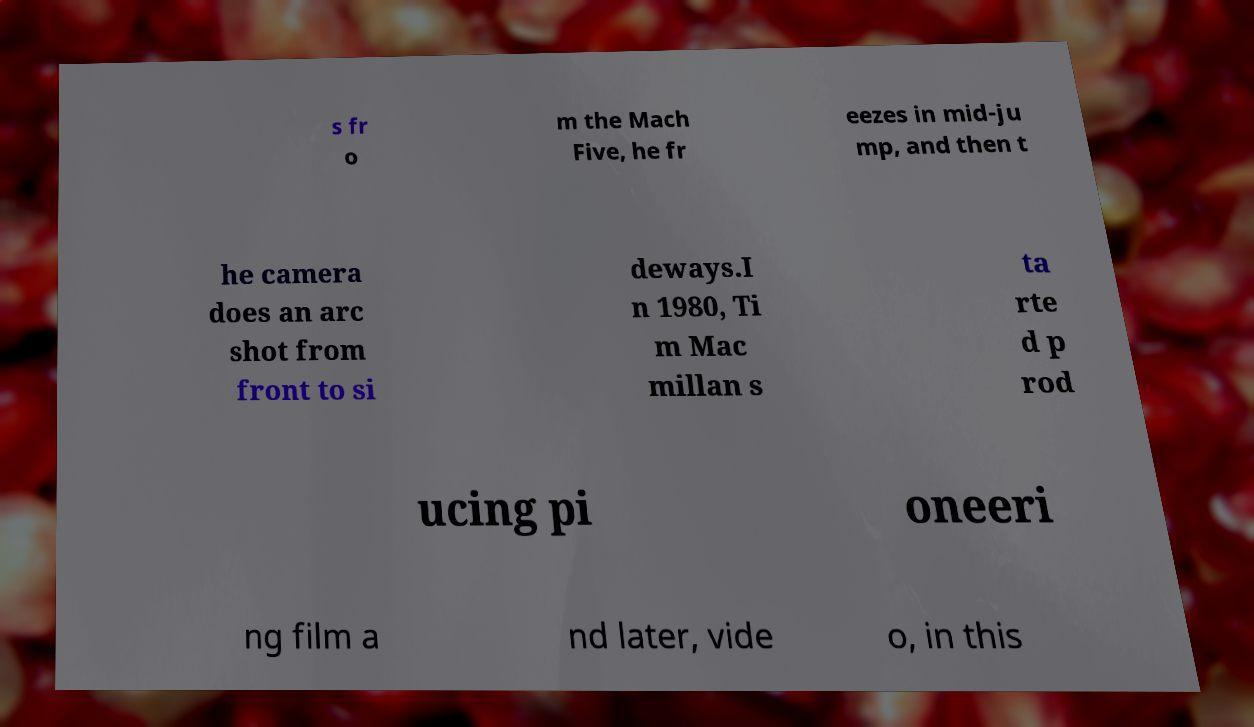For documentation purposes, I need the text within this image transcribed. Could you provide that? s fr o m the Mach Five, he fr eezes in mid-ju mp, and then t he camera does an arc shot from front to si deways.I n 1980, Ti m Mac millan s ta rte d p rod ucing pi oneeri ng film a nd later, vide o, in this 